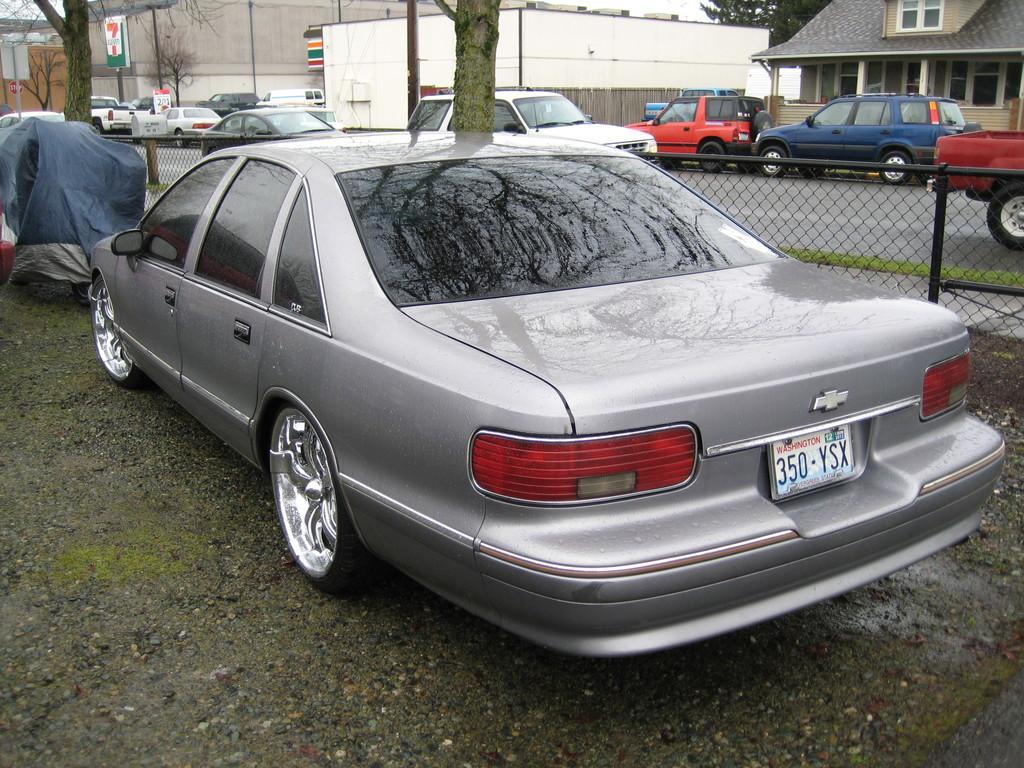Describe this image in one or two sentences. There is a gray color vehicle on the road. Beside this vehicle, there is an iron fence. In the background, there are vehicles on the road, there are buildings and there are trees. 